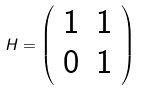<formula> <loc_0><loc_0><loc_500><loc_500>H = \left ( \begin{array} { c c } 1 & 1 \\ 0 & 1 \end{array} \right )</formula> 